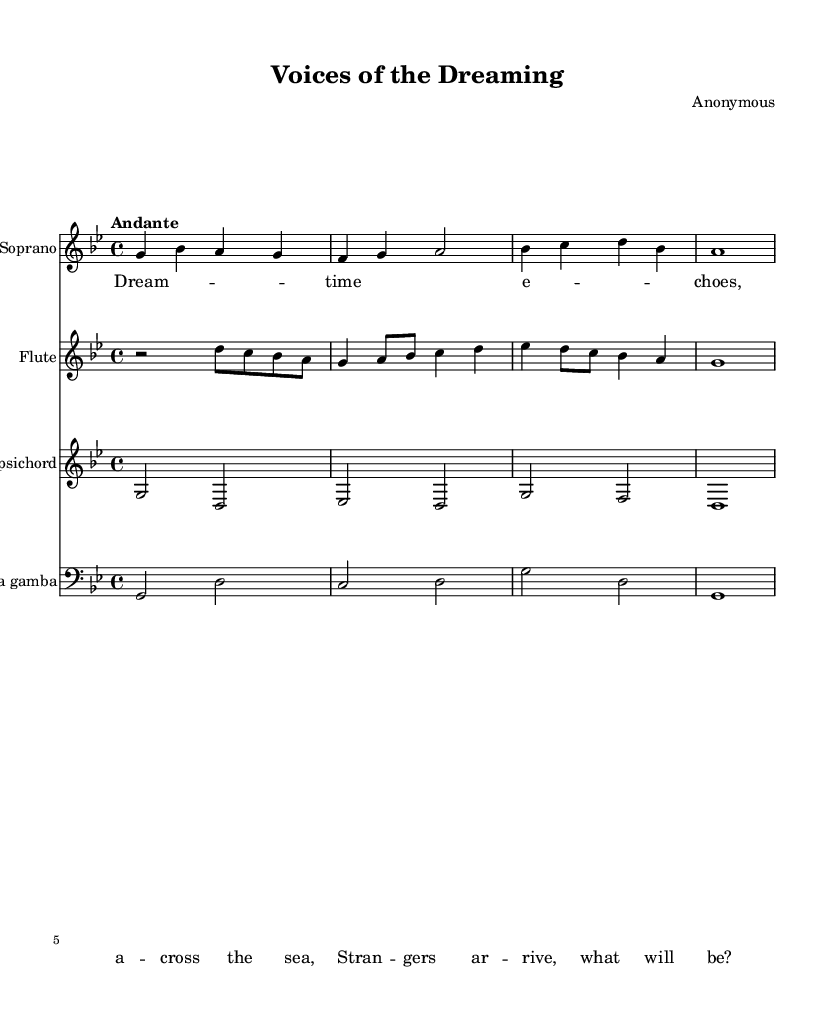What is the key signature of this music? The key signature indicated is G minor, which has two flats (B flat and E flat). You can identify the key signature by looking at the beginning of the staff where the flats are notated.
Answer: G minor What is the time signature of this music? The time signature shown at the beginning of the score is 4/4, meaning there are four beats in a measure and each beat is a quarter note. This can be determined by observing the numbers displayed as the time signature.
Answer: 4/4 What is the tempo marking of this piece? The tempo marking is indicated as "Andante," which suggests a moderately slow tempo. This can be found near the start of the score next to the musical instructions.
Answer: Andante How many instruments are featured in this score? There are four instruments in the score: Soprano, Flute, Harpsichord, and Viola da Gamba. You can see these instruments listed on their respective staves at the beginning.
Answer: Four Which instrument has the lowest pitch in this piece? The instrument with the lowest pitch in this score is the Viola da Gamba, as it is notated in bass clef, while the other instruments are in treble clef or piano staff. The notation of the clef gives a clear indication of the pitch range.
Answer: Viola da Gamba What is the lyrical theme conveyed in the verse? The verse reflects themes of cultural exchange and the arrival of strangers, suggesting a narrative surrounding colonization and dreaming of connection across seas. This can be inferred from analyzing the text provided below the staff.
Answer: Cultural exchange Does this music follow the typical structure of Baroque opera? Yes, this music follows the typical structure of Baroque opera, as it incorporates soprano and instrumental parts, along with a lyrical narrative that is common in operatic compositions of this era. You can determine this by considering the musical arrangement and the song's format.
Answer: Yes 